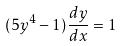<formula> <loc_0><loc_0><loc_500><loc_500>( 5 y ^ { 4 } - 1 ) \frac { d y } { d x } = 1</formula> 